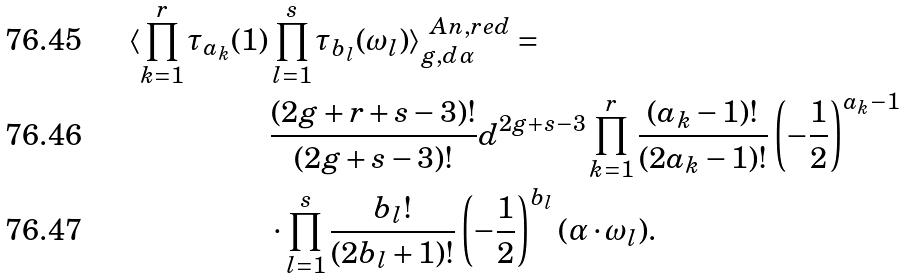<formula> <loc_0><loc_0><loc_500><loc_500>\langle \prod _ { k = 1 } ^ { r } \tau _ { a _ { k } } ( 1 ) & \prod _ { l = 1 } ^ { s } \tau _ { b _ { l } } ( \omega _ { l } ) \rangle ^ { \ A n , r e d } _ { g , d \alpha } = \\ & \frac { ( 2 g + r + s - 3 ) ! } { ( 2 g + s - 3 ) ! } d ^ { 2 g + s - 3 } \prod _ { k = 1 } ^ { r } \frac { ( a _ { k } - 1 ) ! } { ( 2 a _ { k } - 1 ) ! } \left ( - \frac { 1 } { 2 } \right ) ^ { a _ { k } - 1 } \\ & \cdot \prod _ { l = 1 } ^ { s } \frac { b _ { l } ! } { ( 2 b _ { l } + 1 ) ! } \left ( - \frac { 1 } { 2 } \right ) ^ { b _ { l } } ( \alpha \cdot \omega _ { l } ) .</formula> 